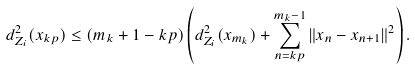<formula> <loc_0><loc_0><loc_500><loc_500>d ^ { 2 } _ { Z _ { i } } ( x _ { k p } ) \leq ( m _ { k } + 1 - k p ) \left ( d ^ { 2 } _ { Z _ { i } } ( x _ { m _ { k } } ) + \sum _ { n = k p } ^ { m _ { k } - 1 } \| x _ { n } - x _ { n + 1 } \| ^ { 2 } \right ) .</formula> 